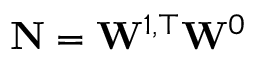<formula> <loc_0><loc_0><loc_500><loc_500>\mathbf N = \mathbf W ^ { 1 , \top } \mathbf W ^ { 0 }</formula> 